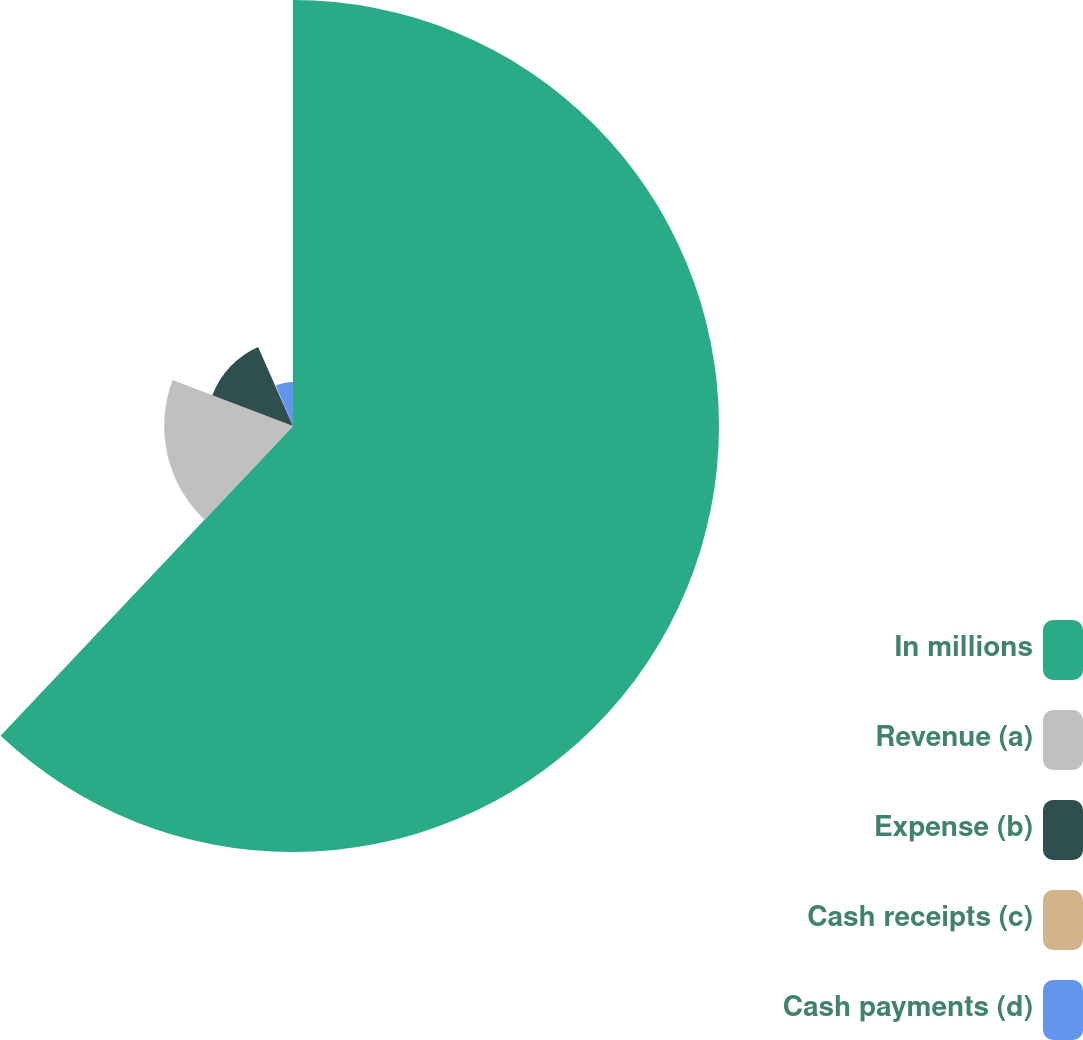Convert chart to OTSL. <chart><loc_0><loc_0><loc_500><loc_500><pie_chart><fcel>In millions<fcel>Revenue (a)<fcel>Expense (b)<fcel>Cash receipts (c)<fcel>Cash payments (d)<nl><fcel>62.04%<fcel>18.76%<fcel>12.58%<fcel>0.22%<fcel>6.4%<nl></chart> 